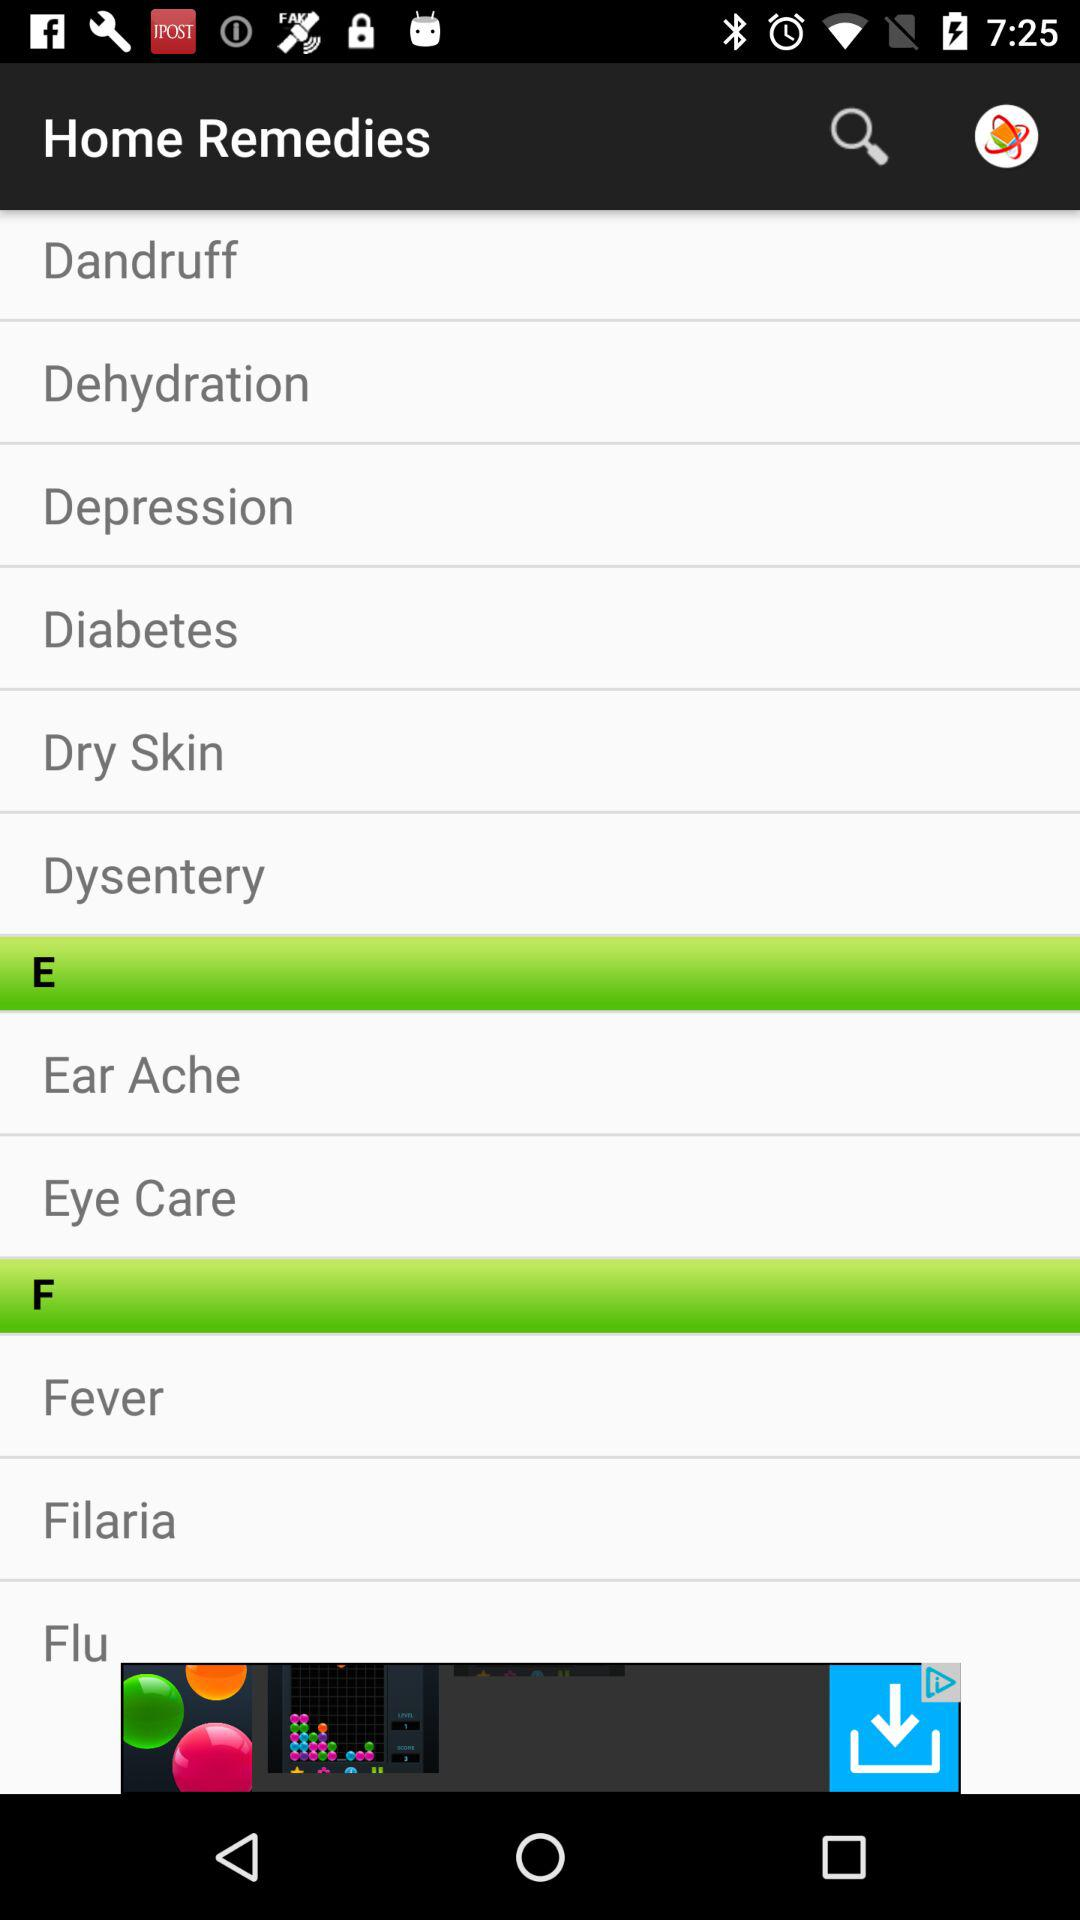What are the diseases listed under the alphabet E? The diseases are "Ear Ache" and "Eye Care". 